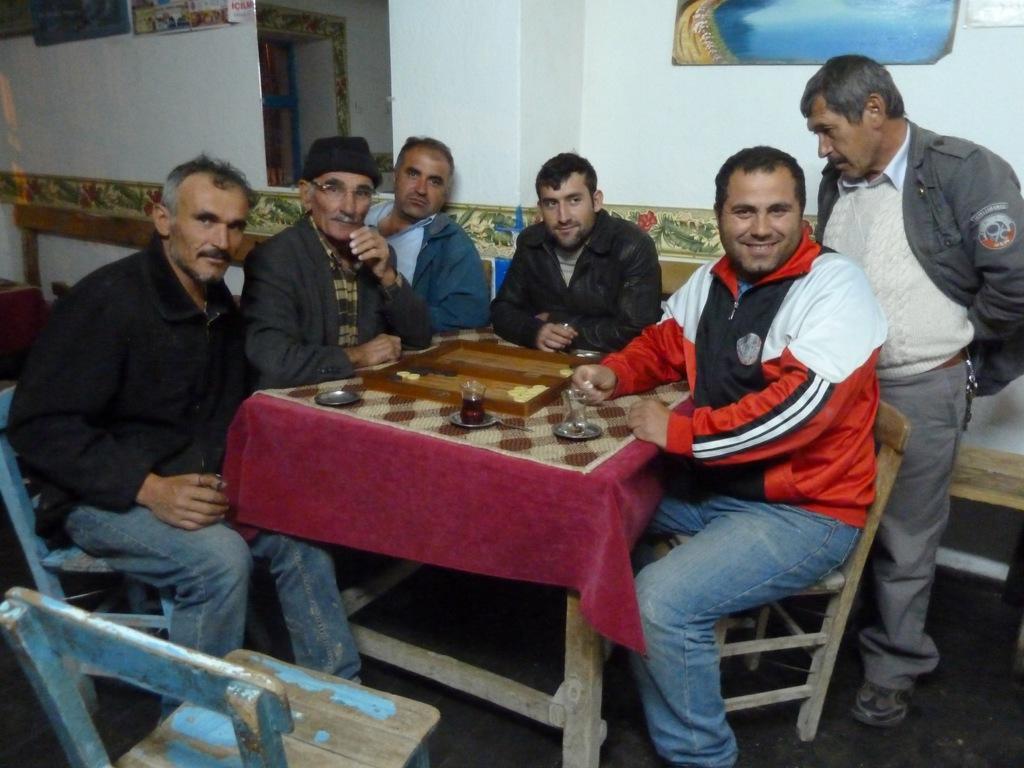In one or two sentences, can you explain what this image depicts? In this picture, we see many men sitting on chair. Man on the right corner of the picture wearing black jacket who is standing is looking looking the glass which is on the table. In the middle of the picture, we see a table on which we see glass, plate. Behind these people, we see a white wall on which photo frame is placed. 